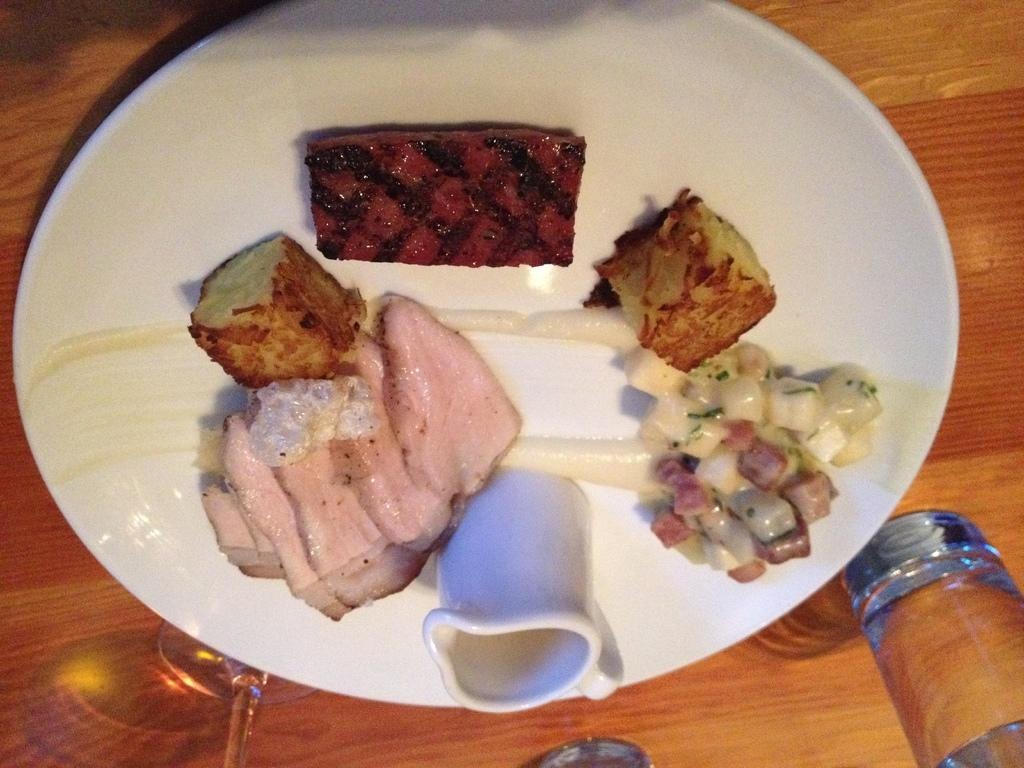What is on the table in the image? There is a plate on a table in the image. What is on the plate? There are food items on the plate. What else can be seen on the table besides the plate? There are glasses present in the image. How many chickens are sitting on the plate in the image? There are no chickens present on the plate or in the image. What type of popcorn can be seen in the image? There is no popcorn present in the image. 